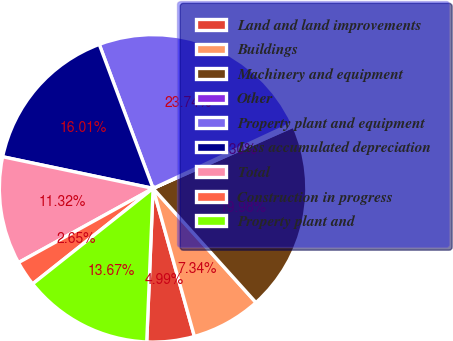Convert chart to OTSL. <chart><loc_0><loc_0><loc_500><loc_500><pie_chart><fcel>Land and land improvements<fcel>Buildings<fcel>Machinery and equipment<fcel>Other<fcel>Property plant and equipment<fcel>Less accumulated depreciation<fcel>Total<fcel>Construction in progress<fcel>Property plant and<nl><fcel>4.99%<fcel>7.34%<fcel>19.98%<fcel>0.3%<fcel>23.74%<fcel>16.01%<fcel>11.32%<fcel>2.65%<fcel>13.67%<nl></chart> 